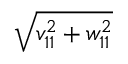<formula> <loc_0><loc_0><loc_500><loc_500>\sqrt { v _ { 1 1 } ^ { 2 } + w _ { 1 1 } ^ { 2 } }</formula> 